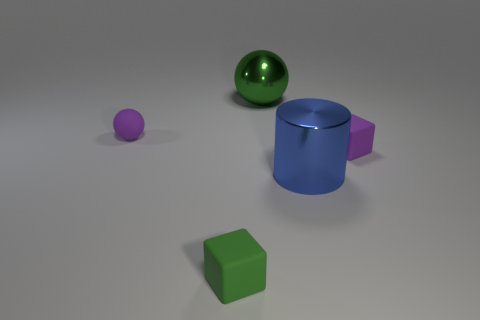What is the material of the ball that is the same size as the green rubber thing?
Your answer should be compact. Rubber. There is a purple ball that is behind the purple block; is its size the same as the green block?
Make the answer very short. Yes. Do the small purple matte object to the right of the tiny matte ball and the green rubber object have the same shape?
Keep it short and to the point. Yes. How many objects are large green metallic things or shiny objects behind the large blue object?
Provide a short and direct response. 1. Is the number of yellow shiny objects less than the number of green spheres?
Provide a succinct answer. Yes. Are there more red cylinders than rubber blocks?
Your answer should be very brief. No. How many other things are made of the same material as the cylinder?
Ensure brevity in your answer.  1. What number of small matte objects are in front of the purple matte object in front of the object that is to the left of the small green thing?
Give a very brief answer. 1. What number of shiny things are either purple blocks or green cubes?
Your answer should be compact. 0. What size is the green matte cube that is left of the purple matte object that is right of the big metallic cylinder?
Your response must be concise. Small. 